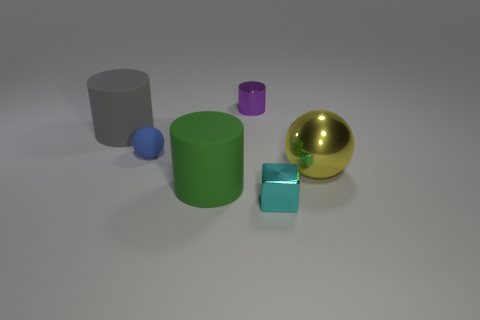Is the color of the small metallic thing on the right side of the tiny purple metal object the same as the ball that is right of the small purple metal object?
Provide a short and direct response. No. What size is the purple shiny cylinder?
Your answer should be very brief. Small. How many big things are either gray things or balls?
Provide a succinct answer. 2. There is a ball that is the same size as the gray cylinder; what color is it?
Your answer should be compact. Yellow. How many other things are the same shape as the purple object?
Give a very brief answer. 2. Are there any large gray things made of the same material as the small ball?
Offer a very short reply. Yes. Is the ball that is on the left side of the tiny cylinder made of the same material as the big object to the right of the tiny cube?
Your answer should be very brief. No. How many red rubber spheres are there?
Ensure brevity in your answer.  0. There is a small metallic thing that is on the left side of the tiny cyan block; what is its shape?
Offer a very short reply. Cylinder. What number of other objects are the same size as the blue sphere?
Keep it short and to the point. 2. 